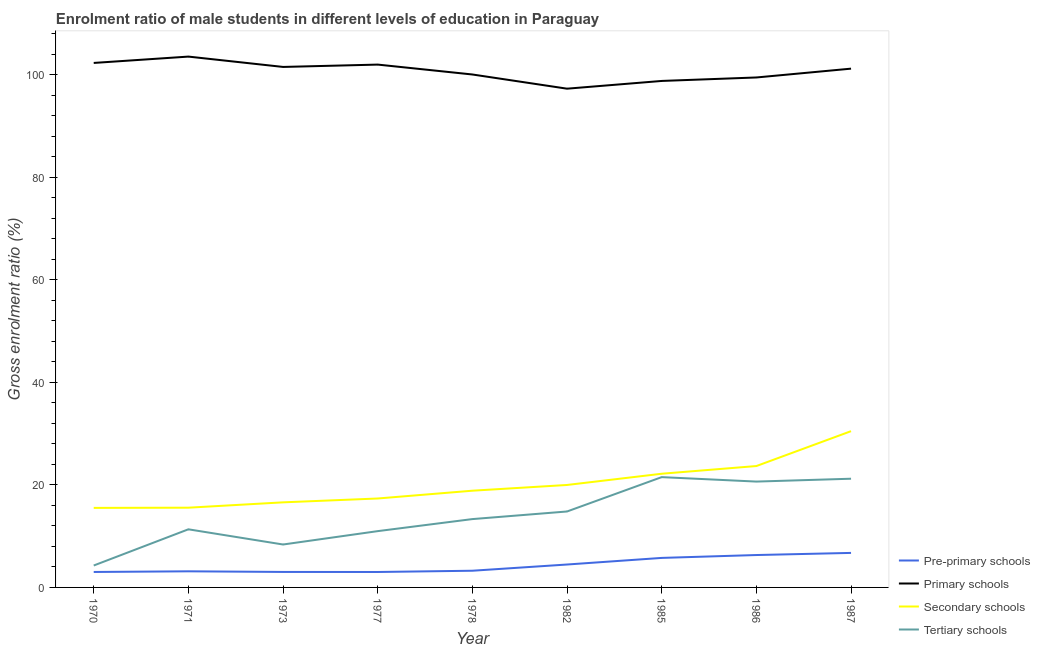Is the number of lines equal to the number of legend labels?
Offer a terse response. Yes. What is the gross enrolment ratio(female) in tertiary schools in 1977?
Make the answer very short. 10.99. Across all years, what is the maximum gross enrolment ratio(female) in tertiary schools?
Your answer should be compact. 21.53. Across all years, what is the minimum gross enrolment ratio(female) in tertiary schools?
Make the answer very short. 4.28. What is the total gross enrolment ratio(female) in primary schools in the graph?
Provide a succinct answer. 906.55. What is the difference between the gross enrolment ratio(female) in pre-primary schools in 1982 and that in 1987?
Provide a succinct answer. -2.26. What is the difference between the gross enrolment ratio(female) in tertiary schools in 1971 and the gross enrolment ratio(female) in pre-primary schools in 1973?
Offer a terse response. 8.32. What is the average gross enrolment ratio(female) in tertiary schools per year?
Ensure brevity in your answer.  14.06. In the year 1970, what is the difference between the gross enrolment ratio(female) in secondary schools and gross enrolment ratio(female) in primary schools?
Make the answer very short. -86.83. In how many years, is the gross enrolment ratio(female) in pre-primary schools greater than 4 %?
Provide a succinct answer. 4. What is the ratio of the gross enrolment ratio(female) in pre-primary schools in 1978 to that in 1985?
Give a very brief answer. 0.57. Is the difference between the gross enrolment ratio(female) in secondary schools in 1986 and 1987 greater than the difference between the gross enrolment ratio(female) in pre-primary schools in 1986 and 1987?
Keep it short and to the point. No. What is the difference between the highest and the second highest gross enrolment ratio(female) in pre-primary schools?
Keep it short and to the point. 0.41. What is the difference between the highest and the lowest gross enrolment ratio(female) in tertiary schools?
Keep it short and to the point. 17.25. Is the sum of the gross enrolment ratio(female) in primary schools in 1973 and 1978 greater than the maximum gross enrolment ratio(female) in pre-primary schools across all years?
Keep it short and to the point. Yes. Is it the case that in every year, the sum of the gross enrolment ratio(female) in pre-primary schools and gross enrolment ratio(female) in primary schools is greater than the sum of gross enrolment ratio(female) in secondary schools and gross enrolment ratio(female) in tertiary schools?
Offer a very short reply. Yes. Is it the case that in every year, the sum of the gross enrolment ratio(female) in pre-primary schools and gross enrolment ratio(female) in primary schools is greater than the gross enrolment ratio(female) in secondary schools?
Offer a very short reply. Yes. Does the gross enrolment ratio(female) in primary schools monotonically increase over the years?
Keep it short and to the point. No. How many lines are there?
Provide a short and direct response. 4. How many years are there in the graph?
Provide a short and direct response. 9. Are the values on the major ticks of Y-axis written in scientific E-notation?
Provide a short and direct response. No. Does the graph contain grids?
Your answer should be compact. No. How many legend labels are there?
Keep it short and to the point. 4. What is the title of the graph?
Provide a short and direct response. Enrolment ratio of male students in different levels of education in Paraguay. Does "WFP" appear as one of the legend labels in the graph?
Keep it short and to the point. No. What is the Gross enrolment ratio (%) of Pre-primary schools in 1970?
Ensure brevity in your answer.  3.02. What is the Gross enrolment ratio (%) in Primary schools in 1970?
Offer a very short reply. 102.35. What is the Gross enrolment ratio (%) of Secondary schools in 1970?
Offer a very short reply. 15.52. What is the Gross enrolment ratio (%) in Tertiary schools in 1970?
Provide a succinct answer. 4.28. What is the Gross enrolment ratio (%) of Pre-primary schools in 1971?
Your answer should be very brief. 3.14. What is the Gross enrolment ratio (%) in Primary schools in 1971?
Give a very brief answer. 103.59. What is the Gross enrolment ratio (%) of Secondary schools in 1971?
Keep it short and to the point. 15.56. What is the Gross enrolment ratio (%) in Tertiary schools in 1971?
Provide a short and direct response. 11.34. What is the Gross enrolment ratio (%) in Pre-primary schools in 1973?
Your answer should be very brief. 3.02. What is the Gross enrolment ratio (%) in Primary schools in 1973?
Your response must be concise. 101.57. What is the Gross enrolment ratio (%) in Secondary schools in 1973?
Provide a succinct answer. 16.6. What is the Gross enrolment ratio (%) in Tertiary schools in 1973?
Your answer should be compact. 8.38. What is the Gross enrolment ratio (%) of Pre-primary schools in 1977?
Your answer should be compact. 3.01. What is the Gross enrolment ratio (%) of Primary schools in 1977?
Your response must be concise. 102.03. What is the Gross enrolment ratio (%) in Secondary schools in 1977?
Provide a succinct answer. 17.36. What is the Gross enrolment ratio (%) of Tertiary schools in 1977?
Make the answer very short. 10.99. What is the Gross enrolment ratio (%) of Pre-primary schools in 1978?
Your answer should be compact. 3.26. What is the Gross enrolment ratio (%) of Primary schools in 1978?
Your answer should be very brief. 100.1. What is the Gross enrolment ratio (%) in Secondary schools in 1978?
Offer a very short reply. 18.88. What is the Gross enrolment ratio (%) of Tertiary schools in 1978?
Offer a terse response. 13.34. What is the Gross enrolment ratio (%) of Pre-primary schools in 1982?
Your answer should be compact. 4.47. What is the Gross enrolment ratio (%) of Primary schools in 1982?
Keep it short and to the point. 97.33. What is the Gross enrolment ratio (%) of Secondary schools in 1982?
Your response must be concise. 19.99. What is the Gross enrolment ratio (%) of Tertiary schools in 1982?
Provide a succinct answer. 14.82. What is the Gross enrolment ratio (%) of Pre-primary schools in 1985?
Offer a very short reply. 5.76. What is the Gross enrolment ratio (%) in Primary schools in 1985?
Your answer should be very brief. 98.84. What is the Gross enrolment ratio (%) in Secondary schools in 1985?
Give a very brief answer. 22.19. What is the Gross enrolment ratio (%) in Tertiary schools in 1985?
Keep it short and to the point. 21.53. What is the Gross enrolment ratio (%) of Pre-primary schools in 1986?
Your answer should be compact. 6.32. What is the Gross enrolment ratio (%) in Primary schools in 1986?
Your answer should be compact. 99.51. What is the Gross enrolment ratio (%) in Secondary schools in 1986?
Provide a succinct answer. 23.69. What is the Gross enrolment ratio (%) in Tertiary schools in 1986?
Provide a short and direct response. 20.66. What is the Gross enrolment ratio (%) of Pre-primary schools in 1987?
Offer a terse response. 6.74. What is the Gross enrolment ratio (%) in Primary schools in 1987?
Keep it short and to the point. 101.24. What is the Gross enrolment ratio (%) of Secondary schools in 1987?
Offer a terse response. 30.49. What is the Gross enrolment ratio (%) in Tertiary schools in 1987?
Your response must be concise. 21.21. Across all years, what is the maximum Gross enrolment ratio (%) in Pre-primary schools?
Offer a terse response. 6.74. Across all years, what is the maximum Gross enrolment ratio (%) of Primary schools?
Offer a terse response. 103.59. Across all years, what is the maximum Gross enrolment ratio (%) in Secondary schools?
Provide a short and direct response. 30.49. Across all years, what is the maximum Gross enrolment ratio (%) of Tertiary schools?
Provide a succinct answer. 21.53. Across all years, what is the minimum Gross enrolment ratio (%) in Pre-primary schools?
Ensure brevity in your answer.  3.01. Across all years, what is the minimum Gross enrolment ratio (%) of Primary schools?
Your answer should be compact. 97.33. Across all years, what is the minimum Gross enrolment ratio (%) of Secondary schools?
Provide a short and direct response. 15.52. Across all years, what is the minimum Gross enrolment ratio (%) of Tertiary schools?
Keep it short and to the point. 4.28. What is the total Gross enrolment ratio (%) of Pre-primary schools in the graph?
Give a very brief answer. 38.74. What is the total Gross enrolment ratio (%) in Primary schools in the graph?
Ensure brevity in your answer.  906.55. What is the total Gross enrolment ratio (%) in Secondary schools in the graph?
Offer a very short reply. 180.28. What is the total Gross enrolment ratio (%) of Tertiary schools in the graph?
Provide a short and direct response. 126.53. What is the difference between the Gross enrolment ratio (%) of Pre-primary schools in 1970 and that in 1971?
Keep it short and to the point. -0.13. What is the difference between the Gross enrolment ratio (%) in Primary schools in 1970 and that in 1971?
Provide a short and direct response. -1.24. What is the difference between the Gross enrolment ratio (%) of Secondary schools in 1970 and that in 1971?
Your answer should be very brief. -0.04. What is the difference between the Gross enrolment ratio (%) in Tertiary schools in 1970 and that in 1971?
Provide a short and direct response. -7.06. What is the difference between the Gross enrolment ratio (%) of Pre-primary schools in 1970 and that in 1973?
Offer a very short reply. -0.01. What is the difference between the Gross enrolment ratio (%) in Primary schools in 1970 and that in 1973?
Your answer should be compact. 0.78. What is the difference between the Gross enrolment ratio (%) in Secondary schools in 1970 and that in 1973?
Your answer should be very brief. -1.08. What is the difference between the Gross enrolment ratio (%) in Tertiary schools in 1970 and that in 1973?
Keep it short and to the point. -4.1. What is the difference between the Gross enrolment ratio (%) of Pre-primary schools in 1970 and that in 1977?
Keep it short and to the point. 0. What is the difference between the Gross enrolment ratio (%) of Primary schools in 1970 and that in 1977?
Ensure brevity in your answer.  0.32. What is the difference between the Gross enrolment ratio (%) of Secondary schools in 1970 and that in 1977?
Give a very brief answer. -1.83. What is the difference between the Gross enrolment ratio (%) of Tertiary schools in 1970 and that in 1977?
Your response must be concise. -6.71. What is the difference between the Gross enrolment ratio (%) in Pre-primary schools in 1970 and that in 1978?
Your response must be concise. -0.24. What is the difference between the Gross enrolment ratio (%) of Primary schools in 1970 and that in 1978?
Your response must be concise. 2.25. What is the difference between the Gross enrolment ratio (%) in Secondary schools in 1970 and that in 1978?
Your answer should be compact. -3.35. What is the difference between the Gross enrolment ratio (%) of Tertiary schools in 1970 and that in 1978?
Your answer should be very brief. -9.06. What is the difference between the Gross enrolment ratio (%) of Pre-primary schools in 1970 and that in 1982?
Your answer should be compact. -1.45. What is the difference between the Gross enrolment ratio (%) of Primary schools in 1970 and that in 1982?
Offer a very short reply. 5.02. What is the difference between the Gross enrolment ratio (%) in Secondary schools in 1970 and that in 1982?
Your response must be concise. -4.47. What is the difference between the Gross enrolment ratio (%) of Tertiary schools in 1970 and that in 1982?
Your answer should be compact. -10.54. What is the difference between the Gross enrolment ratio (%) in Pre-primary schools in 1970 and that in 1985?
Your response must be concise. -2.74. What is the difference between the Gross enrolment ratio (%) of Primary schools in 1970 and that in 1985?
Your answer should be compact. 3.51. What is the difference between the Gross enrolment ratio (%) of Secondary schools in 1970 and that in 1985?
Keep it short and to the point. -6.66. What is the difference between the Gross enrolment ratio (%) of Tertiary schools in 1970 and that in 1985?
Ensure brevity in your answer.  -17.25. What is the difference between the Gross enrolment ratio (%) in Pre-primary schools in 1970 and that in 1986?
Your response must be concise. -3.31. What is the difference between the Gross enrolment ratio (%) in Primary schools in 1970 and that in 1986?
Make the answer very short. 2.84. What is the difference between the Gross enrolment ratio (%) in Secondary schools in 1970 and that in 1986?
Provide a succinct answer. -8.17. What is the difference between the Gross enrolment ratio (%) in Tertiary schools in 1970 and that in 1986?
Keep it short and to the point. -16.38. What is the difference between the Gross enrolment ratio (%) of Pre-primary schools in 1970 and that in 1987?
Keep it short and to the point. -3.72. What is the difference between the Gross enrolment ratio (%) in Primary schools in 1970 and that in 1987?
Ensure brevity in your answer.  1.11. What is the difference between the Gross enrolment ratio (%) of Secondary schools in 1970 and that in 1987?
Make the answer very short. -14.97. What is the difference between the Gross enrolment ratio (%) of Tertiary schools in 1970 and that in 1987?
Offer a terse response. -16.94. What is the difference between the Gross enrolment ratio (%) in Pre-primary schools in 1971 and that in 1973?
Offer a very short reply. 0.12. What is the difference between the Gross enrolment ratio (%) in Primary schools in 1971 and that in 1973?
Give a very brief answer. 2.02. What is the difference between the Gross enrolment ratio (%) of Secondary schools in 1971 and that in 1973?
Keep it short and to the point. -1.04. What is the difference between the Gross enrolment ratio (%) of Tertiary schools in 1971 and that in 1973?
Give a very brief answer. 2.97. What is the difference between the Gross enrolment ratio (%) in Pre-primary schools in 1971 and that in 1977?
Provide a short and direct response. 0.13. What is the difference between the Gross enrolment ratio (%) of Primary schools in 1971 and that in 1977?
Provide a succinct answer. 1.56. What is the difference between the Gross enrolment ratio (%) of Secondary schools in 1971 and that in 1977?
Your response must be concise. -1.79. What is the difference between the Gross enrolment ratio (%) in Tertiary schools in 1971 and that in 1977?
Give a very brief answer. 0.36. What is the difference between the Gross enrolment ratio (%) of Pre-primary schools in 1971 and that in 1978?
Provide a succinct answer. -0.11. What is the difference between the Gross enrolment ratio (%) in Primary schools in 1971 and that in 1978?
Provide a short and direct response. 3.49. What is the difference between the Gross enrolment ratio (%) in Secondary schools in 1971 and that in 1978?
Keep it short and to the point. -3.32. What is the difference between the Gross enrolment ratio (%) in Tertiary schools in 1971 and that in 1978?
Keep it short and to the point. -1.99. What is the difference between the Gross enrolment ratio (%) in Pre-primary schools in 1971 and that in 1982?
Your answer should be very brief. -1.33. What is the difference between the Gross enrolment ratio (%) of Primary schools in 1971 and that in 1982?
Your answer should be compact. 6.26. What is the difference between the Gross enrolment ratio (%) in Secondary schools in 1971 and that in 1982?
Keep it short and to the point. -4.43. What is the difference between the Gross enrolment ratio (%) of Tertiary schools in 1971 and that in 1982?
Keep it short and to the point. -3.48. What is the difference between the Gross enrolment ratio (%) in Pre-primary schools in 1971 and that in 1985?
Give a very brief answer. -2.62. What is the difference between the Gross enrolment ratio (%) of Primary schools in 1971 and that in 1985?
Ensure brevity in your answer.  4.75. What is the difference between the Gross enrolment ratio (%) in Secondary schools in 1971 and that in 1985?
Your answer should be compact. -6.63. What is the difference between the Gross enrolment ratio (%) in Tertiary schools in 1971 and that in 1985?
Ensure brevity in your answer.  -10.18. What is the difference between the Gross enrolment ratio (%) of Pre-primary schools in 1971 and that in 1986?
Give a very brief answer. -3.18. What is the difference between the Gross enrolment ratio (%) of Primary schools in 1971 and that in 1986?
Offer a terse response. 4.07. What is the difference between the Gross enrolment ratio (%) of Secondary schools in 1971 and that in 1986?
Your answer should be compact. -8.13. What is the difference between the Gross enrolment ratio (%) in Tertiary schools in 1971 and that in 1986?
Your answer should be compact. -9.31. What is the difference between the Gross enrolment ratio (%) in Pre-primary schools in 1971 and that in 1987?
Offer a very short reply. -3.59. What is the difference between the Gross enrolment ratio (%) of Primary schools in 1971 and that in 1987?
Ensure brevity in your answer.  2.35. What is the difference between the Gross enrolment ratio (%) of Secondary schools in 1971 and that in 1987?
Make the answer very short. -14.93. What is the difference between the Gross enrolment ratio (%) of Tertiary schools in 1971 and that in 1987?
Make the answer very short. -9.87. What is the difference between the Gross enrolment ratio (%) of Pre-primary schools in 1973 and that in 1977?
Keep it short and to the point. 0.01. What is the difference between the Gross enrolment ratio (%) in Primary schools in 1973 and that in 1977?
Provide a short and direct response. -0.46. What is the difference between the Gross enrolment ratio (%) of Secondary schools in 1973 and that in 1977?
Provide a succinct answer. -0.75. What is the difference between the Gross enrolment ratio (%) of Tertiary schools in 1973 and that in 1977?
Make the answer very short. -2.61. What is the difference between the Gross enrolment ratio (%) in Pre-primary schools in 1973 and that in 1978?
Your response must be concise. -0.23. What is the difference between the Gross enrolment ratio (%) in Primary schools in 1973 and that in 1978?
Offer a very short reply. 1.47. What is the difference between the Gross enrolment ratio (%) of Secondary schools in 1973 and that in 1978?
Provide a succinct answer. -2.27. What is the difference between the Gross enrolment ratio (%) of Tertiary schools in 1973 and that in 1978?
Ensure brevity in your answer.  -4.96. What is the difference between the Gross enrolment ratio (%) in Pre-primary schools in 1973 and that in 1982?
Keep it short and to the point. -1.45. What is the difference between the Gross enrolment ratio (%) in Primary schools in 1973 and that in 1982?
Keep it short and to the point. 4.24. What is the difference between the Gross enrolment ratio (%) of Secondary schools in 1973 and that in 1982?
Provide a succinct answer. -3.39. What is the difference between the Gross enrolment ratio (%) in Tertiary schools in 1973 and that in 1982?
Make the answer very short. -6.44. What is the difference between the Gross enrolment ratio (%) in Pre-primary schools in 1973 and that in 1985?
Your response must be concise. -2.74. What is the difference between the Gross enrolment ratio (%) of Primary schools in 1973 and that in 1985?
Your answer should be compact. 2.73. What is the difference between the Gross enrolment ratio (%) in Secondary schools in 1973 and that in 1985?
Your response must be concise. -5.58. What is the difference between the Gross enrolment ratio (%) in Tertiary schools in 1973 and that in 1985?
Keep it short and to the point. -13.15. What is the difference between the Gross enrolment ratio (%) in Pre-primary schools in 1973 and that in 1986?
Your answer should be very brief. -3.3. What is the difference between the Gross enrolment ratio (%) of Primary schools in 1973 and that in 1986?
Your answer should be compact. 2.06. What is the difference between the Gross enrolment ratio (%) in Secondary schools in 1973 and that in 1986?
Your response must be concise. -7.08. What is the difference between the Gross enrolment ratio (%) of Tertiary schools in 1973 and that in 1986?
Make the answer very short. -12.28. What is the difference between the Gross enrolment ratio (%) in Pre-primary schools in 1973 and that in 1987?
Your response must be concise. -3.71. What is the difference between the Gross enrolment ratio (%) of Primary schools in 1973 and that in 1987?
Your answer should be compact. 0.34. What is the difference between the Gross enrolment ratio (%) of Secondary schools in 1973 and that in 1987?
Provide a succinct answer. -13.89. What is the difference between the Gross enrolment ratio (%) in Tertiary schools in 1973 and that in 1987?
Offer a terse response. -12.84. What is the difference between the Gross enrolment ratio (%) in Pre-primary schools in 1977 and that in 1978?
Keep it short and to the point. -0.24. What is the difference between the Gross enrolment ratio (%) in Primary schools in 1977 and that in 1978?
Ensure brevity in your answer.  1.93. What is the difference between the Gross enrolment ratio (%) in Secondary schools in 1977 and that in 1978?
Your response must be concise. -1.52. What is the difference between the Gross enrolment ratio (%) in Tertiary schools in 1977 and that in 1978?
Provide a short and direct response. -2.35. What is the difference between the Gross enrolment ratio (%) in Pre-primary schools in 1977 and that in 1982?
Your response must be concise. -1.46. What is the difference between the Gross enrolment ratio (%) in Primary schools in 1977 and that in 1982?
Ensure brevity in your answer.  4.7. What is the difference between the Gross enrolment ratio (%) in Secondary schools in 1977 and that in 1982?
Keep it short and to the point. -2.64. What is the difference between the Gross enrolment ratio (%) of Tertiary schools in 1977 and that in 1982?
Ensure brevity in your answer.  -3.83. What is the difference between the Gross enrolment ratio (%) of Pre-primary schools in 1977 and that in 1985?
Your answer should be very brief. -2.75. What is the difference between the Gross enrolment ratio (%) in Primary schools in 1977 and that in 1985?
Make the answer very short. 3.19. What is the difference between the Gross enrolment ratio (%) of Secondary schools in 1977 and that in 1985?
Ensure brevity in your answer.  -4.83. What is the difference between the Gross enrolment ratio (%) of Tertiary schools in 1977 and that in 1985?
Your answer should be compact. -10.54. What is the difference between the Gross enrolment ratio (%) of Pre-primary schools in 1977 and that in 1986?
Ensure brevity in your answer.  -3.31. What is the difference between the Gross enrolment ratio (%) in Primary schools in 1977 and that in 1986?
Ensure brevity in your answer.  2.51. What is the difference between the Gross enrolment ratio (%) of Secondary schools in 1977 and that in 1986?
Give a very brief answer. -6.33. What is the difference between the Gross enrolment ratio (%) in Tertiary schools in 1977 and that in 1986?
Offer a very short reply. -9.67. What is the difference between the Gross enrolment ratio (%) in Pre-primary schools in 1977 and that in 1987?
Your answer should be compact. -3.72. What is the difference between the Gross enrolment ratio (%) in Primary schools in 1977 and that in 1987?
Your answer should be compact. 0.79. What is the difference between the Gross enrolment ratio (%) in Secondary schools in 1977 and that in 1987?
Make the answer very short. -13.14. What is the difference between the Gross enrolment ratio (%) of Tertiary schools in 1977 and that in 1987?
Keep it short and to the point. -10.23. What is the difference between the Gross enrolment ratio (%) in Pre-primary schools in 1978 and that in 1982?
Give a very brief answer. -1.21. What is the difference between the Gross enrolment ratio (%) in Primary schools in 1978 and that in 1982?
Give a very brief answer. 2.77. What is the difference between the Gross enrolment ratio (%) of Secondary schools in 1978 and that in 1982?
Provide a short and direct response. -1.12. What is the difference between the Gross enrolment ratio (%) in Tertiary schools in 1978 and that in 1982?
Keep it short and to the point. -1.48. What is the difference between the Gross enrolment ratio (%) in Pre-primary schools in 1978 and that in 1985?
Offer a very short reply. -2.5. What is the difference between the Gross enrolment ratio (%) in Primary schools in 1978 and that in 1985?
Offer a very short reply. 1.26. What is the difference between the Gross enrolment ratio (%) in Secondary schools in 1978 and that in 1985?
Provide a succinct answer. -3.31. What is the difference between the Gross enrolment ratio (%) of Tertiary schools in 1978 and that in 1985?
Provide a succinct answer. -8.19. What is the difference between the Gross enrolment ratio (%) in Pre-primary schools in 1978 and that in 1986?
Offer a very short reply. -3.06. What is the difference between the Gross enrolment ratio (%) of Primary schools in 1978 and that in 1986?
Your answer should be very brief. 0.58. What is the difference between the Gross enrolment ratio (%) of Secondary schools in 1978 and that in 1986?
Make the answer very short. -4.81. What is the difference between the Gross enrolment ratio (%) of Tertiary schools in 1978 and that in 1986?
Ensure brevity in your answer.  -7.32. What is the difference between the Gross enrolment ratio (%) in Pre-primary schools in 1978 and that in 1987?
Offer a terse response. -3.48. What is the difference between the Gross enrolment ratio (%) of Primary schools in 1978 and that in 1987?
Ensure brevity in your answer.  -1.14. What is the difference between the Gross enrolment ratio (%) in Secondary schools in 1978 and that in 1987?
Your response must be concise. -11.62. What is the difference between the Gross enrolment ratio (%) of Tertiary schools in 1978 and that in 1987?
Your response must be concise. -7.88. What is the difference between the Gross enrolment ratio (%) in Pre-primary schools in 1982 and that in 1985?
Give a very brief answer. -1.29. What is the difference between the Gross enrolment ratio (%) of Primary schools in 1982 and that in 1985?
Your answer should be compact. -1.51. What is the difference between the Gross enrolment ratio (%) in Secondary schools in 1982 and that in 1985?
Keep it short and to the point. -2.19. What is the difference between the Gross enrolment ratio (%) of Tertiary schools in 1982 and that in 1985?
Your response must be concise. -6.71. What is the difference between the Gross enrolment ratio (%) in Pre-primary schools in 1982 and that in 1986?
Provide a succinct answer. -1.85. What is the difference between the Gross enrolment ratio (%) of Primary schools in 1982 and that in 1986?
Provide a succinct answer. -2.19. What is the difference between the Gross enrolment ratio (%) of Secondary schools in 1982 and that in 1986?
Your answer should be very brief. -3.69. What is the difference between the Gross enrolment ratio (%) of Tertiary schools in 1982 and that in 1986?
Offer a terse response. -5.84. What is the difference between the Gross enrolment ratio (%) of Pre-primary schools in 1982 and that in 1987?
Offer a very short reply. -2.26. What is the difference between the Gross enrolment ratio (%) in Primary schools in 1982 and that in 1987?
Provide a short and direct response. -3.91. What is the difference between the Gross enrolment ratio (%) in Secondary schools in 1982 and that in 1987?
Your answer should be very brief. -10.5. What is the difference between the Gross enrolment ratio (%) in Tertiary schools in 1982 and that in 1987?
Provide a short and direct response. -6.39. What is the difference between the Gross enrolment ratio (%) of Pre-primary schools in 1985 and that in 1986?
Keep it short and to the point. -0.56. What is the difference between the Gross enrolment ratio (%) in Primary schools in 1985 and that in 1986?
Give a very brief answer. -0.68. What is the difference between the Gross enrolment ratio (%) of Secondary schools in 1985 and that in 1986?
Make the answer very short. -1.5. What is the difference between the Gross enrolment ratio (%) in Tertiary schools in 1985 and that in 1986?
Give a very brief answer. 0.87. What is the difference between the Gross enrolment ratio (%) in Pre-primary schools in 1985 and that in 1987?
Ensure brevity in your answer.  -0.98. What is the difference between the Gross enrolment ratio (%) in Primary schools in 1985 and that in 1987?
Provide a short and direct response. -2.4. What is the difference between the Gross enrolment ratio (%) of Secondary schools in 1985 and that in 1987?
Provide a short and direct response. -8.31. What is the difference between the Gross enrolment ratio (%) of Tertiary schools in 1985 and that in 1987?
Your answer should be compact. 0.31. What is the difference between the Gross enrolment ratio (%) in Pre-primary schools in 1986 and that in 1987?
Offer a very short reply. -0.41. What is the difference between the Gross enrolment ratio (%) in Primary schools in 1986 and that in 1987?
Make the answer very short. -1.72. What is the difference between the Gross enrolment ratio (%) in Secondary schools in 1986 and that in 1987?
Your response must be concise. -6.81. What is the difference between the Gross enrolment ratio (%) in Tertiary schools in 1986 and that in 1987?
Provide a short and direct response. -0.56. What is the difference between the Gross enrolment ratio (%) in Pre-primary schools in 1970 and the Gross enrolment ratio (%) in Primary schools in 1971?
Make the answer very short. -100.57. What is the difference between the Gross enrolment ratio (%) in Pre-primary schools in 1970 and the Gross enrolment ratio (%) in Secondary schools in 1971?
Your answer should be compact. -12.54. What is the difference between the Gross enrolment ratio (%) of Pre-primary schools in 1970 and the Gross enrolment ratio (%) of Tertiary schools in 1971?
Provide a short and direct response. -8.33. What is the difference between the Gross enrolment ratio (%) of Primary schools in 1970 and the Gross enrolment ratio (%) of Secondary schools in 1971?
Ensure brevity in your answer.  86.79. What is the difference between the Gross enrolment ratio (%) of Primary schools in 1970 and the Gross enrolment ratio (%) of Tertiary schools in 1971?
Keep it short and to the point. 91.01. What is the difference between the Gross enrolment ratio (%) in Secondary schools in 1970 and the Gross enrolment ratio (%) in Tertiary schools in 1971?
Your response must be concise. 4.18. What is the difference between the Gross enrolment ratio (%) of Pre-primary schools in 1970 and the Gross enrolment ratio (%) of Primary schools in 1973?
Ensure brevity in your answer.  -98.55. What is the difference between the Gross enrolment ratio (%) of Pre-primary schools in 1970 and the Gross enrolment ratio (%) of Secondary schools in 1973?
Offer a terse response. -13.59. What is the difference between the Gross enrolment ratio (%) in Pre-primary schools in 1970 and the Gross enrolment ratio (%) in Tertiary schools in 1973?
Keep it short and to the point. -5.36. What is the difference between the Gross enrolment ratio (%) in Primary schools in 1970 and the Gross enrolment ratio (%) in Secondary schools in 1973?
Your answer should be compact. 85.75. What is the difference between the Gross enrolment ratio (%) of Primary schools in 1970 and the Gross enrolment ratio (%) of Tertiary schools in 1973?
Give a very brief answer. 93.97. What is the difference between the Gross enrolment ratio (%) in Secondary schools in 1970 and the Gross enrolment ratio (%) in Tertiary schools in 1973?
Your answer should be compact. 7.14. What is the difference between the Gross enrolment ratio (%) of Pre-primary schools in 1970 and the Gross enrolment ratio (%) of Primary schools in 1977?
Give a very brief answer. -99.01. What is the difference between the Gross enrolment ratio (%) of Pre-primary schools in 1970 and the Gross enrolment ratio (%) of Secondary schools in 1977?
Provide a short and direct response. -14.34. What is the difference between the Gross enrolment ratio (%) in Pre-primary schools in 1970 and the Gross enrolment ratio (%) in Tertiary schools in 1977?
Give a very brief answer. -7.97. What is the difference between the Gross enrolment ratio (%) of Primary schools in 1970 and the Gross enrolment ratio (%) of Secondary schools in 1977?
Your response must be concise. 85. What is the difference between the Gross enrolment ratio (%) in Primary schools in 1970 and the Gross enrolment ratio (%) in Tertiary schools in 1977?
Provide a short and direct response. 91.36. What is the difference between the Gross enrolment ratio (%) in Secondary schools in 1970 and the Gross enrolment ratio (%) in Tertiary schools in 1977?
Keep it short and to the point. 4.54. What is the difference between the Gross enrolment ratio (%) of Pre-primary schools in 1970 and the Gross enrolment ratio (%) of Primary schools in 1978?
Keep it short and to the point. -97.08. What is the difference between the Gross enrolment ratio (%) of Pre-primary schools in 1970 and the Gross enrolment ratio (%) of Secondary schools in 1978?
Keep it short and to the point. -15.86. What is the difference between the Gross enrolment ratio (%) in Pre-primary schools in 1970 and the Gross enrolment ratio (%) in Tertiary schools in 1978?
Provide a succinct answer. -10.32. What is the difference between the Gross enrolment ratio (%) of Primary schools in 1970 and the Gross enrolment ratio (%) of Secondary schools in 1978?
Offer a very short reply. 83.47. What is the difference between the Gross enrolment ratio (%) in Primary schools in 1970 and the Gross enrolment ratio (%) in Tertiary schools in 1978?
Provide a succinct answer. 89.02. What is the difference between the Gross enrolment ratio (%) of Secondary schools in 1970 and the Gross enrolment ratio (%) of Tertiary schools in 1978?
Provide a succinct answer. 2.19. What is the difference between the Gross enrolment ratio (%) of Pre-primary schools in 1970 and the Gross enrolment ratio (%) of Primary schools in 1982?
Your answer should be compact. -94.31. What is the difference between the Gross enrolment ratio (%) in Pre-primary schools in 1970 and the Gross enrolment ratio (%) in Secondary schools in 1982?
Offer a very short reply. -16.98. What is the difference between the Gross enrolment ratio (%) of Pre-primary schools in 1970 and the Gross enrolment ratio (%) of Tertiary schools in 1982?
Your answer should be very brief. -11.8. What is the difference between the Gross enrolment ratio (%) of Primary schools in 1970 and the Gross enrolment ratio (%) of Secondary schools in 1982?
Offer a very short reply. 82.36. What is the difference between the Gross enrolment ratio (%) of Primary schools in 1970 and the Gross enrolment ratio (%) of Tertiary schools in 1982?
Offer a terse response. 87.53. What is the difference between the Gross enrolment ratio (%) in Secondary schools in 1970 and the Gross enrolment ratio (%) in Tertiary schools in 1982?
Your response must be concise. 0.7. What is the difference between the Gross enrolment ratio (%) of Pre-primary schools in 1970 and the Gross enrolment ratio (%) of Primary schools in 1985?
Offer a terse response. -95.82. What is the difference between the Gross enrolment ratio (%) in Pre-primary schools in 1970 and the Gross enrolment ratio (%) in Secondary schools in 1985?
Keep it short and to the point. -19.17. What is the difference between the Gross enrolment ratio (%) of Pre-primary schools in 1970 and the Gross enrolment ratio (%) of Tertiary schools in 1985?
Ensure brevity in your answer.  -18.51. What is the difference between the Gross enrolment ratio (%) in Primary schools in 1970 and the Gross enrolment ratio (%) in Secondary schools in 1985?
Your response must be concise. 80.16. What is the difference between the Gross enrolment ratio (%) in Primary schools in 1970 and the Gross enrolment ratio (%) in Tertiary schools in 1985?
Keep it short and to the point. 80.82. What is the difference between the Gross enrolment ratio (%) of Secondary schools in 1970 and the Gross enrolment ratio (%) of Tertiary schools in 1985?
Offer a very short reply. -6. What is the difference between the Gross enrolment ratio (%) in Pre-primary schools in 1970 and the Gross enrolment ratio (%) in Primary schools in 1986?
Keep it short and to the point. -96.5. What is the difference between the Gross enrolment ratio (%) in Pre-primary schools in 1970 and the Gross enrolment ratio (%) in Secondary schools in 1986?
Provide a succinct answer. -20.67. What is the difference between the Gross enrolment ratio (%) in Pre-primary schools in 1970 and the Gross enrolment ratio (%) in Tertiary schools in 1986?
Keep it short and to the point. -17.64. What is the difference between the Gross enrolment ratio (%) of Primary schools in 1970 and the Gross enrolment ratio (%) of Secondary schools in 1986?
Make the answer very short. 78.66. What is the difference between the Gross enrolment ratio (%) of Primary schools in 1970 and the Gross enrolment ratio (%) of Tertiary schools in 1986?
Provide a short and direct response. 81.69. What is the difference between the Gross enrolment ratio (%) of Secondary schools in 1970 and the Gross enrolment ratio (%) of Tertiary schools in 1986?
Your answer should be compact. -5.13. What is the difference between the Gross enrolment ratio (%) of Pre-primary schools in 1970 and the Gross enrolment ratio (%) of Primary schools in 1987?
Your answer should be very brief. -98.22. What is the difference between the Gross enrolment ratio (%) of Pre-primary schools in 1970 and the Gross enrolment ratio (%) of Secondary schools in 1987?
Give a very brief answer. -27.48. What is the difference between the Gross enrolment ratio (%) in Pre-primary schools in 1970 and the Gross enrolment ratio (%) in Tertiary schools in 1987?
Keep it short and to the point. -18.2. What is the difference between the Gross enrolment ratio (%) of Primary schools in 1970 and the Gross enrolment ratio (%) of Secondary schools in 1987?
Your response must be concise. 71.86. What is the difference between the Gross enrolment ratio (%) of Primary schools in 1970 and the Gross enrolment ratio (%) of Tertiary schools in 1987?
Offer a terse response. 81.14. What is the difference between the Gross enrolment ratio (%) of Secondary schools in 1970 and the Gross enrolment ratio (%) of Tertiary schools in 1987?
Keep it short and to the point. -5.69. What is the difference between the Gross enrolment ratio (%) of Pre-primary schools in 1971 and the Gross enrolment ratio (%) of Primary schools in 1973?
Ensure brevity in your answer.  -98.43. What is the difference between the Gross enrolment ratio (%) of Pre-primary schools in 1971 and the Gross enrolment ratio (%) of Secondary schools in 1973?
Your answer should be compact. -13.46. What is the difference between the Gross enrolment ratio (%) of Pre-primary schools in 1971 and the Gross enrolment ratio (%) of Tertiary schools in 1973?
Your answer should be compact. -5.23. What is the difference between the Gross enrolment ratio (%) in Primary schools in 1971 and the Gross enrolment ratio (%) in Secondary schools in 1973?
Ensure brevity in your answer.  86.99. What is the difference between the Gross enrolment ratio (%) of Primary schools in 1971 and the Gross enrolment ratio (%) of Tertiary schools in 1973?
Give a very brief answer. 95.21. What is the difference between the Gross enrolment ratio (%) of Secondary schools in 1971 and the Gross enrolment ratio (%) of Tertiary schools in 1973?
Your response must be concise. 7.18. What is the difference between the Gross enrolment ratio (%) of Pre-primary schools in 1971 and the Gross enrolment ratio (%) of Primary schools in 1977?
Provide a short and direct response. -98.88. What is the difference between the Gross enrolment ratio (%) of Pre-primary schools in 1971 and the Gross enrolment ratio (%) of Secondary schools in 1977?
Give a very brief answer. -14.21. What is the difference between the Gross enrolment ratio (%) in Pre-primary schools in 1971 and the Gross enrolment ratio (%) in Tertiary schools in 1977?
Your answer should be compact. -7.84. What is the difference between the Gross enrolment ratio (%) in Primary schools in 1971 and the Gross enrolment ratio (%) in Secondary schools in 1977?
Ensure brevity in your answer.  86.23. What is the difference between the Gross enrolment ratio (%) in Primary schools in 1971 and the Gross enrolment ratio (%) in Tertiary schools in 1977?
Keep it short and to the point. 92.6. What is the difference between the Gross enrolment ratio (%) in Secondary schools in 1971 and the Gross enrolment ratio (%) in Tertiary schools in 1977?
Ensure brevity in your answer.  4.57. What is the difference between the Gross enrolment ratio (%) of Pre-primary schools in 1971 and the Gross enrolment ratio (%) of Primary schools in 1978?
Offer a very short reply. -96.95. What is the difference between the Gross enrolment ratio (%) of Pre-primary schools in 1971 and the Gross enrolment ratio (%) of Secondary schools in 1978?
Provide a succinct answer. -15.73. What is the difference between the Gross enrolment ratio (%) in Pre-primary schools in 1971 and the Gross enrolment ratio (%) in Tertiary schools in 1978?
Ensure brevity in your answer.  -10.19. What is the difference between the Gross enrolment ratio (%) in Primary schools in 1971 and the Gross enrolment ratio (%) in Secondary schools in 1978?
Offer a terse response. 84.71. What is the difference between the Gross enrolment ratio (%) of Primary schools in 1971 and the Gross enrolment ratio (%) of Tertiary schools in 1978?
Your answer should be compact. 90.25. What is the difference between the Gross enrolment ratio (%) of Secondary schools in 1971 and the Gross enrolment ratio (%) of Tertiary schools in 1978?
Offer a terse response. 2.23. What is the difference between the Gross enrolment ratio (%) of Pre-primary schools in 1971 and the Gross enrolment ratio (%) of Primary schools in 1982?
Your response must be concise. -94.18. What is the difference between the Gross enrolment ratio (%) in Pre-primary schools in 1971 and the Gross enrolment ratio (%) in Secondary schools in 1982?
Give a very brief answer. -16.85. What is the difference between the Gross enrolment ratio (%) in Pre-primary schools in 1971 and the Gross enrolment ratio (%) in Tertiary schools in 1982?
Your answer should be compact. -11.67. What is the difference between the Gross enrolment ratio (%) of Primary schools in 1971 and the Gross enrolment ratio (%) of Secondary schools in 1982?
Ensure brevity in your answer.  83.59. What is the difference between the Gross enrolment ratio (%) in Primary schools in 1971 and the Gross enrolment ratio (%) in Tertiary schools in 1982?
Offer a very short reply. 88.77. What is the difference between the Gross enrolment ratio (%) of Secondary schools in 1971 and the Gross enrolment ratio (%) of Tertiary schools in 1982?
Your response must be concise. 0.74. What is the difference between the Gross enrolment ratio (%) in Pre-primary schools in 1971 and the Gross enrolment ratio (%) in Primary schools in 1985?
Offer a very short reply. -95.69. What is the difference between the Gross enrolment ratio (%) in Pre-primary schools in 1971 and the Gross enrolment ratio (%) in Secondary schools in 1985?
Offer a very short reply. -19.04. What is the difference between the Gross enrolment ratio (%) in Pre-primary schools in 1971 and the Gross enrolment ratio (%) in Tertiary schools in 1985?
Give a very brief answer. -18.38. What is the difference between the Gross enrolment ratio (%) in Primary schools in 1971 and the Gross enrolment ratio (%) in Secondary schools in 1985?
Make the answer very short. 81.4. What is the difference between the Gross enrolment ratio (%) in Primary schools in 1971 and the Gross enrolment ratio (%) in Tertiary schools in 1985?
Provide a succinct answer. 82.06. What is the difference between the Gross enrolment ratio (%) of Secondary schools in 1971 and the Gross enrolment ratio (%) of Tertiary schools in 1985?
Ensure brevity in your answer.  -5.97. What is the difference between the Gross enrolment ratio (%) in Pre-primary schools in 1971 and the Gross enrolment ratio (%) in Primary schools in 1986?
Offer a very short reply. -96.37. What is the difference between the Gross enrolment ratio (%) in Pre-primary schools in 1971 and the Gross enrolment ratio (%) in Secondary schools in 1986?
Your response must be concise. -20.54. What is the difference between the Gross enrolment ratio (%) of Pre-primary schools in 1971 and the Gross enrolment ratio (%) of Tertiary schools in 1986?
Give a very brief answer. -17.51. What is the difference between the Gross enrolment ratio (%) of Primary schools in 1971 and the Gross enrolment ratio (%) of Secondary schools in 1986?
Your answer should be very brief. 79.9. What is the difference between the Gross enrolment ratio (%) in Primary schools in 1971 and the Gross enrolment ratio (%) in Tertiary schools in 1986?
Keep it short and to the point. 82.93. What is the difference between the Gross enrolment ratio (%) of Secondary schools in 1971 and the Gross enrolment ratio (%) of Tertiary schools in 1986?
Make the answer very short. -5.1. What is the difference between the Gross enrolment ratio (%) of Pre-primary schools in 1971 and the Gross enrolment ratio (%) of Primary schools in 1987?
Your response must be concise. -98.09. What is the difference between the Gross enrolment ratio (%) in Pre-primary schools in 1971 and the Gross enrolment ratio (%) in Secondary schools in 1987?
Give a very brief answer. -27.35. What is the difference between the Gross enrolment ratio (%) of Pre-primary schools in 1971 and the Gross enrolment ratio (%) of Tertiary schools in 1987?
Your answer should be very brief. -18.07. What is the difference between the Gross enrolment ratio (%) in Primary schools in 1971 and the Gross enrolment ratio (%) in Secondary schools in 1987?
Provide a short and direct response. 73.1. What is the difference between the Gross enrolment ratio (%) in Primary schools in 1971 and the Gross enrolment ratio (%) in Tertiary schools in 1987?
Provide a succinct answer. 82.38. What is the difference between the Gross enrolment ratio (%) in Secondary schools in 1971 and the Gross enrolment ratio (%) in Tertiary schools in 1987?
Give a very brief answer. -5.65. What is the difference between the Gross enrolment ratio (%) of Pre-primary schools in 1973 and the Gross enrolment ratio (%) of Primary schools in 1977?
Your answer should be compact. -99.01. What is the difference between the Gross enrolment ratio (%) in Pre-primary schools in 1973 and the Gross enrolment ratio (%) in Secondary schools in 1977?
Provide a short and direct response. -14.33. What is the difference between the Gross enrolment ratio (%) in Pre-primary schools in 1973 and the Gross enrolment ratio (%) in Tertiary schools in 1977?
Make the answer very short. -7.96. What is the difference between the Gross enrolment ratio (%) of Primary schools in 1973 and the Gross enrolment ratio (%) of Secondary schools in 1977?
Offer a very short reply. 84.22. What is the difference between the Gross enrolment ratio (%) in Primary schools in 1973 and the Gross enrolment ratio (%) in Tertiary schools in 1977?
Ensure brevity in your answer.  90.59. What is the difference between the Gross enrolment ratio (%) in Secondary schools in 1973 and the Gross enrolment ratio (%) in Tertiary schools in 1977?
Make the answer very short. 5.62. What is the difference between the Gross enrolment ratio (%) of Pre-primary schools in 1973 and the Gross enrolment ratio (%) of Primary schools in 1978?
Provide a short and direct response. -97.07. What is the difference between the Gross enrolment ratio (%) of Pre-primary schools in 1973 and the Gross enrolment ratio (%) of Secondary schools in 1978?
Ensure brevity in your answer.  -15.85. What is the difference between the Gross enrolment ratio (%) in Pre-primary schools in 1973 and the Gross enrolment ratio (%) in Tertiary schools in 1978?
Offer a terse response. -10.31. What is the difference between the Gross enrolment ratio (%) in Primary schools in 1973 and the Gross enrolment ratio (%) in Secondary schools in 1978?
Provide a short and direct response. 82.7. What is the difference between the Gross enrolment ratio (%) of Primary schools in 1973 and the Gross enrolment ratio (%) of Tertiary schools in 1978?
Offer a terse response. 88.24. What is the difference between the Gross enrolment ratio (%) in Secondary schools in 1973 and the Gross enrolment ratio (%) in Tertiary schools in 1978?
Ensure brevity in your answer.  3.27. What is the difference between the Gross enrolment ratio (%) in Pre-primary schools in 1973 and the Gross enrolment ratio (%) in Primary schools in 1982?
Ensure brevity in your answer.  -94.3. What is the difference between the Gross enrolment ratio (%) of Pre-primary schools in 1973 and the Gross enrolment ratio (%) of Secondary schools in 1982?
Provide a succinct answer. -16.97. What is the difference between the Gross enrolment ratio (%) in Pre-primary schools in 1973 and the Gross enrolment ratio (%) in Tertiary schools in 1982?
Ensure brevity in your answer.  -11.8. What is the difference between the Gross enrolment ratio (%) in Primary schools in 1973 and the Gross enrolment ratio (%) in Secondary schools in 1982?
Your answer should be very brief. 81.58. What is the difference between the Gross enrolment ratio (%) in Primary schools in 1973 and the Gross enrolment ratio (%) in Tertiary schools in 1982?
Provide a succinct answer. 86.75. What is the difference between the Gross enrolment ratio (%) of Secondary schools in 1973 and the Gross enrolment ratio (%) of Tertiary schools in 1982?
Keep it short and to the point. 1.78. What is the difference between the Gross enrolment ratio (%) of Pre-primary schools in 1973 and the Gross enrolment ratio (%) of Primary schools in 1985?
Your answer should be very brief. -95.81. What is the difference between the Gross enrolment ratio (%) of Pre-primary schools in 1973 and the Gross enrolment ratio (%) of Secondary schools in 1985?
Keep it short and to the point. -19.16. What is the difference between the Gross enrolment ratio (%) of Pre-primary schools in 1973 and the Gross enrolment ratio (%) of Tertiary schools in 1985?
Provide a short and direct response. -18.5. What is the difference between the Gross enrolment ratio (%) of Primary schools in 1973 and the Gross enrolment ratio (%) of Secondary schools in 1985?
Ensure brevity in your answer.  79.39. What is the difference between the Gross enrolment ratio (%) of Primary schools in 1973 and the Gross enrolment ratio (%) of Tertiary schools in 1985?
Offer a very short reply. 80.05. What is the difference between the Gross enrolment ratio (%) in Secondary schools in 1973 and the Gross enrolment ratio (%) in Tertiary schools in 1985?
Your response must be concise. -4.92. What is the difference between the Gross enrolment ratio (%) of Pre-primary schools in 1973 and the Gross enrolment ratio (%) of Primary schools in 1986?
Offer a very short reply. -96.49. What is the difference between the Gross enrolment ratio (%) in Pre-primary schools in 1973 and the Gross enrolment ratio (%) in Secondary schools in 1986?
Give a very brief answer. -20.66. What is the difference between the Gross enrolment ratio (%) of Pre-primary schools in 1973 and the Gross enrolment ratio (%) of Tertiary schools in 1986?
Your answer should be very brief. -17.63. What is the difference between the Gross enrolment ratio (%) of Primary schools in 1973 and the Gross enrolment ratio (%) of Secondary schools in 1986?
Offer a terse response. 77.88. What is the difference between the Gross enrolment ratio (%) of Primary schools in 1973 and the Gross enrolment ratio (%) of Tertiary schools in 1986?
Your answer should be very brief. 80.92. What is the difference between the Gross enrolment ratio (%) of Secondary schools in 1973 and the Gross enrolment ratio (%) of Tertiary schools in 1986?
Your answer should be compact. -4.05. What is the difference between the Gross enrolment ratio (%) in Pre-primary schools in 1973 and the Gross enrolment ratio (%) in Primary schools in 1987?
Provide a succinct answer. -98.21. What is the difference between the Gross enrolment ratio (%) in Pre-primary schools in 1973 and the Gross enrolment ratio (%) in Secondary schools in 1987?
Offer a terse response. -27.47. What is the difference between the Gross enrolment ratio (%) of Pre-primary schools in 1973 and the Gross enrolment ratio (%) of Tertiary schools in 1987?
Provide a succinct answer. -18.19. What is the difference between the Gross enrolment ratio (%) in Primary schools in 1973 and the Gross enrolment ratio (%) in Secondary schools in 1987?
Provide a short and direct response. 71.08. What is the difference between the Gross enrolment ratio (%) of Primary schools in 1973 and the Gross enrolment ratio (%) of Tertiary schools in 1987?
Give a very brief answer. 80.36. What is the difference between the Gross enrolment ratio (%) in Secondary schools in 1973 and the Gross enrolment ratio (%) in Tertiary schools in 1987?
Offer a very short reply. -4.61. What is the difference between the Gross enrolment ratio (%) of Pre-primary schools in 1977 and the Gross enrolment ratio (%) of Primary schools in 1978?
Offer a very short reply. -97.08. What is the difference between the Gross enrolment ratio (%) of Pre-primary schools in 1977 and the Gross enrolment ratio (%) of Secondary schools in 1978?
Your response must be concise. -15.86. What is the difference between the Gross enrolment ratio (%) of Pre-primary schools in 1977 and the Gross enrolment ratio (%) of Tertiary schools in 1978?
Keep it short and to the point. -10.32. What is the difference between the Gross enrolment ratio (%) in Primary schools in 1977 and the Gross enrolment ratio (%) in Secondary schools in 1978?
Keep it short and to the point. 83.15. What is the difference between the Gross enrolment ratio (%) in Primary schools in 1977 and the Gross enrolment ratio (%) in Tertiary schools in 1978?
Make the answer very short. 88.69. What is the difference between the Gross enrolment ratio (%) in Secondary schools in 1977 and the Gross enrolment ratio (%) in Tertiary schools in 1978?
Offer a very short reply. 4.02. What is the difference between the Gross enrolment ratio (%) of Pre-primary schools in 1977 and the Gross enrolment ratio (%) of Primary schools in 1982?
Make the answer very short. -94.31. What is the difference between the Gross enrolment ratio (%) in Pre-primary schools in 1977 and the Gross enrolment ratio (%) in Secondary schools in 1982?
Your answer should be very brief. -16.98. What is the difference between the Gross enrolment ratio (%) of Pre-primary schools in 1977 and the Gross enrolment ratio (%) of Tertiary schools in 1982?
Ensure brevity in your answer.  -11.81. What is the difference between the Gross enrolment ratio (%) in Primary schools in 1977 and the Gross enrolment ratio (%) in Secondary schools in 1982?
Make the answer very short. 82.03. What is the difference between the Gross enrolment ratio (%) of Primary schools in 1977 and the Gross enrolment ratio (%) of Tertiary schools in 1982?
Your answer should be very brief. 87.21. What is the difference between the Gross enrolment ratio (%) of Secondary schools in 1977 and the Gross enrolment ratio (%) of Tertiary schools in 1982?
Provide a short and direct response. 2.54. What is the difference between the Gross enrolment ratio (%) in Pre-primary schools in 1977 and the Gross enrolment ratio (%) in Primary schools in 1985?
Offer a terse response. -95.82. What is the difference between the Gross enrolment ratio (%) in Pre-primary schools in 1977 and the Gross enrolment ratio (%) in Secondary schools in 1985?
Your response must be concise. -19.17. What is the difference between the Gross enrolment ratio (%) in Pre-primary schools in 1977 and the Gross enrolment ratio (%) in Tertiary schools in 1985?
Offer a very short reply. -18.51. What is the difference between the Gross enrolment ratio (%) of Primary schools in 1977 and the Gross enrolment ratio (%) of Secondary schools in 1985?
Ensure brevity in your answer.  79.84. What is the difference between the Gross enrolment ratio (%) of Primary schools in 1977 and the Gross enrolment ratio (%) of Tertiary schools in 1985?
Your response must be concise. 80.5. What is the difference between the Gross enrolment ratio (%) in Secondary schools in 1977 and the Gross enrolment ratio (%) in Tertiary schools in 1985?
Your answer should be very brief. -4.17. What is the difference between the Gross enrolment ratio (%) of Pre-primary schools in 1977 and the Gross enrolment ratio (%) of Primary schools in 1986?
Provide a succinct answer. -96.5. What is the difference between the Gross enrolment ratio (%) of Pre-primary schools in 1977 and the Gross enrolment ratio (%) of Secondary schools in 1986?
Keep it short and to the point. -20.67. What is the difference between the Gross enrolment ratio (%) of Pre-primary schools in 1977 and the Gross enrolment ratio (%) of Tertiary schools in 1986?
Provide a succinct answer. -17.64. What is the difference between the Gross enrolment ratio (%) of Primary schools in 1977 and the Gross enrolment ratio (%) of Secondary schools in 1986?
Your response must be concise. 78.34. What is the difference between the Gross enrolment ratio (%) of Primary schools in 1977 and the Gross enrolment ratio (%) of Tertiary schools in 1986?
Give a very brief answer. 81.37. What is the difference between the Gross enrolment ratio (%) of Secondary schools in 1977 and the Gross enrolment ratio (%) of Tertiary schools in 1986?
Your answer should be very brief. -3.3. What is the difference between the Gross enrolment ratio (%) in Pre-primary schools in 1977 and the Gross enrolment ratio (%) in Primary schools in 1987?
Ensure brevity in your answer.  -98.22. What is the difference between the Gross enrolment ratio (%) in Pre-primary schools in 1977 and the Gross enrolment ratio (%) in Secondary schools in 1987?
Your response must be concise. -27.48. What is the difference between the Gross enrolment ratio (%) in Pre-primary schools in 1977 and the Gross enrolment ratio (%) in Tertiary schools in 1987?
Make the answer very short. -18.2. What is the difference between the Gross enrolment ratio (%) in Primary schools in 1977 and the Gross enrolment ratio (%) in Secondary schools in 1987?
Make the answer very short. 71.53. What is the difference between the Gross enrolment ratio (%) of Primary schools in 1977 and the Gross enrolment ratio (%) of Tertiary schools in 1987?
Keep it short and to the point. 80.82. What is the difference between the Gross enrolment ratio (%) of Secondary schools in 1977 and the Gross enrolment ratio (%) of Tertiary schools in 1987?
Your answer should be compact. -3.86. What is the difference between the Gross enrolment ratio (%) of Pre-primary schools in 1978 and the Gross enrolment ratio (%) of Primary schools in 1982?
Offer a very short reply. -94.07. What is the difference between the Gross enrolment ratio (%) of Pre-primary schools in 1978 and the Gross enrolment ratio (%) of Secondary schools in 1982?
Ensure brevity in your answer.  -16.74. What is the difference between the Gross enrolment ratio (%) of Pre-primary schools in 1978 and the Gross enrolment ratio (%) of Tertiary schools in 1982?
Provide a succinct answer. -11.56. What is the difference between the Gross enrolment ratio (%) of Primary schools in 1978 and the Gross enrolment ratio (%) of Secondary schools in 1982?
Provide a succinct answer. 80.1. What is the difference between the Gross enrolment ratio (%) in Primary schools in 1978 and the Gross enrolment ratio (%) in Tertiary schools in 1982?
Make the answer very short. 85.28. What is the difference between the Gross enrolment ratio (%) in Secondary schools in 1978 and the Gross enrolment ratio (%) in Tertiary schools in 1982?
Offer a terse response. 4.06. What is the difference between the Gross enrolment ratio (%) of Pre-primary schools in 1978 and the Gross enrolment ratio (%) of Primary schools in 1985?
Give a very brief answer. -95.58. What is the difference between the Gross enrolment ratio (%) in Pre-primary schools in 1978 and the Gross enrolment ratio (%) in Secondary schools in 1985?
Provide a short and direct response. -18.93. What is the difference between the Gross enrolment ratio (%) in Pre-primary schools in 1978 and the Gross enrolment ratio (%) in Tertiary schools in 1985?
Offer a very short reply. -18.27. What is the difference between the Gross enrolment ratio (%) of Primary schools in 1978 and the Gross enrolment ratio (%) of Secondary schools in 1985?
Provide a short and direct response. 77.91. What is the difference between the Gross enrolment ratio (%) in Primary schools in 1978 and the Gross enrolment ratio (%) in Tertiary schools in 1985?
Your response must be concise. 78.57. What is the difference between the Gross enrolment ratio (%) in Secondary schools in 1978 and the Gross enrolment ratio (%) in Tertiary schools in 1985?
Offer a terse response. -2.65. What is the difference between the Gross enrolment ratio (%) of Pre-primary schools in 1978 and the Gross enrolment ratio (%) of Primary schools in 1986?
Ensure brevity in your answer.  -96.26. What is the difference between the Gross enrolment ratio (%) of Pre-primary schools in 1978 and the Gross enrolment ratio (%) of Secondary schools in 1986?
Keep it short and to the point. -20.43. What is the difference between the Gross enrolment ratio (%) of Pre-primary schools in 1978 and the Gross enrolment ratio (%) of Tertiary schools in 1986?
Make the answer very short. -17.4. What is the difference between the Gross enrolment ratio (%) in Primary schools in 1978 and the Gross enrolment ratio (%) in Secondary schools in 1986?
Provide a short and direct response. 76.41. What is the difference between the Gross enrolment ratio (%) of Primary schools in 1978 and the Gross enrolment ratio (%) of Tertiary schools in 1986?
Your answer should be very brief. 79.44. What is the difference between the Gross enrolment ratio (%) in Secondary schools in 1978 and the Gross enrolment ratio (%) in Tertiary schools in 1986?
Offer a terse response. -1.78. What is the difference between the Gross enrolment ratio (%) of Pre-primary schools in 1978 and the Gross enrolment ratio (%) of Primary schools in 1987?
Give a very brief answer. -97.98. What is the difference between the Gross enrolment ratio (%) in Pre-primary schools in 1978 and the Gross enrolment ratio (%) in Secondary schools in 1987?
Your answer should be compact. -27.24. What is the difference between the Gross enrolment ratio (%) in Pre-primary schools in 1978 and the Gross enrolment ratio (%) in Tertiary schools in 1987?
Your response must be concise. -17.96. What is the difference between the Gross enrolment ratio (%) in Primary schools in 1978 and the Gross enrolment ratio (%) in Secondary schools in 1987?
Offer a terse response. 69.6. What is the difference between the Gross enrolment ratio (%) in Primary schools in 1978 and the Gross enrolment ratio (%) in Tertiary schools in 1987?
Ensure brevity in your answer.  78.88. What is the difference between the Gross enrolment ratio (%) in Secondary schools in 1978 and the Gross enrolment ratio (%) in Tertiary schools in 1987?
Make the answer very short. -2.34. What is the difference between the Gross enrolment ratio (%) in Pre-primary schools in 1982 and the Gross enrolment ratio (%) in Primary schools in 1985?
Offer a very short reply. -94.37. What is the difference between the Gross enrolment ratio (%) in Pre-primary schools in 1982 and the Gross enrolment ratio (%) in Secondary schools in 1985?
Your response must be concise. -17.72. What is the difference between the Gross enrolment ratio (%) of Pre-primary schools in 1982 and the Gross enrolment ratio (%) of Tertiary schools in 1985?
Make the answer very short. -17.06. What is the difference between the Gross enrolment ratio (%) in Primary schools in 1982 and the Gross enrolment ratio (%) in Secondary schools in 1985?
Ensure brevity in your answer.  75.14. What is the difference between the Gross enrolment ratio (%) in Primary schools in 1982 and the Gross enrolment ratio (%) in Tertiary schools in 1985?
Keep it short and to the point. 75.8. What is the difference between the Gross enrolment ratio (%) of Secondary schools in 1982 and the Gross enrolment ratio (%) of Tertiary schools in 1985?
Keep it short and to the point. -1.53. What is the difference between the Gross enrolment ratio (%) of Pre-primary schools in 1982 and the Gross enrolment ratio (%) of Primary schools in 1986?
Keep it short and to the point. -95.04. What is the difference between the Gross enrolment ratio (%) of Pre-primary schools in 1982 and the Gross enrolment ratio (%) of Secondary schools in 1986?
Keep it short and to the point. -19.22. What is the difference between the Gross enrolment ratio (%) of Pre-primary schools in 1982 and the Gross enrolment ratio (%) of Tertiary schools in 1986?
Your answer should be compact. -16.19. What is the difference between the Gross enrolment ratio (%) of Primary schools in 1982 and the Gross enrolment ratio (%) of Secondary schools in 1986?
Give a very brief answer. 73.64. What is the difference between the Gross enrolment ratio (%) of Primary schools in 1982 and the Gross enrolment ratio (%) of Tertiary schools in 1986?
Your answer should be very brief. 76.67. What is the difference between the Gross enrolment ratio (%) in Secondary schools in 1982 and the Gross enrolment ratio (%) in Tertiary schools in 1986?
Your answer should be very brief. -0.66. What is the difference between the Gross enrolment ratio (%) of Pre-primary schools in 1982 and the Gross enrolment ratio (%) of Primary schools in 1987?
Offer a terse response. -96.77. What is the difference between the Gross enrolment ratio (%) of Pre-primary schools in 1982 and the Gross enrolment ratio (%) of Secondary schools in 1987?
Provide a short and direct response. -26.02. What is the difference between the Gross enrolment ratio (%) in Pre-primary schools in 1982 and the Gross enrolment ratio (%) in Tertiary schools in 1987?
Keep it short and to the point. -16.74. What is the difference between the Gross enrolment ratio (%) in Primary schools in 1982 and the Gross enrolment ratio (%) in Secondary schools in 1987?
Offer a very short reply. 66.83. What is the difference between the Gross enrolment ratio (%) in Primary schools in 1982 and the Gross enrolment ratio (%) in Tertiary schools in 1987?
Provide a short and direct response. 76.11. What is the difference between the Gross enrolment ratio (%) in Secondary schools in 1982 and the Gross enrolment ratio (%) in Tertiary schools in 1987?
Provide a short and direct response. -1.22. What is the difference between the Gross enrolment ratio (%) in Pre-primary schools in 1985 and the Gross enrolment ratio (%) in Primary schools in 1986?
Give a very brief answer. -93.75. What is the difference between the Gross enrolment ratio (%) of Pre-primary schools in 1985 and the Gross enrolment ratio (%) of Secondary schools in 1986?
Provide a short and direct response. -17.93. What is the difference between the Gross enrolment ratio (%) in Pre-primary schools in 1985 and the Gross enrolment ratio (%) in Tertiary schools in 1986?
Your answer should be compact. -14.9. What is the difference between the Gross enrolment ratio (%) of Primary schools in 1985 and the Gross enrolment ratio (%) of Secondary schools in 1986?
Give a very brief answer. 75.15. What is the difference between the Gross enrolment ratio (%) in Primary schools in 1985 and the Gross enrolment ratio (%) in Tertiary schools in 1986?
Your response must be concise. 78.18. What is the difference between the Gross enrolment ratio (%) in Secondary schools in 1985 and the Gross enrolment ratio (%) in Tertiary schools in 1986?
Ensure brevity in your answer.  1.53. What is the difference between the Gross enrolment ratio (%) in Pre-primary schools in 1985 and the Gross enrolment ratio (%) in Primary schools in 1987?
Make the answer very short. -95.48. What is the difference between the Gross enrolment ratio (%) in Pre-primary schools in 1985 and the Gross enrolment ratio (%) in Secondary schools in 1987?
Offer a very short reply. -24.73. What is the difference between the Gross enrolment ratio (%) of Pre-primary schools in 1985 and the Gross enrolment ratio (%) of Tertiary schools in 1987?
Your response must be concise. -15.45. What is the difference between the Gross enrolment ratio (%) of Primary schools in 1985 and the Gross enrolment ratio (%) of Secondary schools in 1987?
Provide a short and direct response. 68.34. What is the difference between the Gross enrolment ratio (%) in Primary schools in 1985 and the Gross enrolment ratio (%) in Tertiary schools in 1987?
Provide a short and direct response. 77.62. What is the difference between the Gross enrolment ratio (%) in Secondary schools in 1985 and the Gross enrolment ratio (%) in Tertiary schools in 1987?
Offer a terse response. 0.97. What is the difference between the Gross enrolment ratio (%) in Pre-primary schools in 1986 and the Gross enrolment ratio (%) in Primary schools in 1987?
Give a very brief answer. -94.91. What is the difference between the Gross enrolment ratio (%) of Pre-primary schools in 1986 and the Gross enrolment ratio (%) of Secondary schools in 1987?
Offer a terse response. -24.17. What is the difference between the Gross enrolment ratio (%) of Pre-primary schools in 1986 and the Gross enrolment ratio (%) of Tertiary schools in 1987?
Your response must be concise. -14.89. What is the difference between the Gross enrolment ratio (%) of Primary schools in 1986 and the Gross enrolment ratio (%) of Secondary schools in 1987?
Keep it short and to the point. 69.02. What is the difference between the Gross enrolment ratio (%) in Primary schools in 1986 and the Gross enrolment ratio (%) in Tertiary schools in 1987?
Provide a short and direct response. 78.3. What is the difference between the Gross enrolment ratio (%) of Secondary schools in 1986 and the Gross enrolment ratio (%) of Tertiary schools in 1987?
Offer a terse response. 2.47. What is the average Gross enrolment ratio (%) in Pre-primary schools per year?
Make the answer very short. 4.3. What is the average Gross enrolment ratio (%) in Primary schools per year?
Ensure brevity in your answer.  100.73. What is the average Gross enrolment ratio (%) of Secondary schools per year?
Your answer should be compact. 20.03. What is the average Gross enrolment ratio (%) in Tertiary schools per year?
Provide a short and direct response. 14.06. In the year 1970, what is the difference between the Gross enrolment ratio (%) of Pre-primary schools and Gross enrolment ratio (%) of Primary schools?
Give a very brief answer. -99.33. In the year 1970, what is the difference between the Gross enrolment ratio (%) in Pre-primary schools and Gross enrolment ratio (%) in Secondary schools?
Keep it short and to the point. -12.5. In the year 1970, what is the difference between the Gross enrolment ratio (%) in Pre-primary schools and Gross enrolment ratio (%) in Tertiary schools?
Make the answer very short. -1.26. In the year 1970, what is the difference between the Gross enrolment ratio (%) of Primary schools and Gross enrolment ratio (%) of Secondary schools?
Your answer should be compact. 86.83. In the year 1970, what is the difference between the Gross enrolment ratio (%) in Primary schools and Gross enrolment ratio (%) in Tertiary schools?
Provide a succinct answer. 98.07. In the year 1970, what is the difference between the Gross enrolment ratio (%) in Secondary schools and Gross enrolment ratio (%) in Tertiary schools?
Provide a succinct answer. 11.24. In the year 1971, what is the difference between the Gross enrolment ratio (%) in Pre-primary schools and Gross enrolment ratio (%) in Primary schools?
Provide a short and direct response. -100.44. In the year 1971, what is the difference between the Gross enrolment ratio (%) in Pre-primary schools and Gross enrolment ratio (%) in Secondary schools?
Offer a very short reply. -12.42. In the year 1971, what is the difference between the Gross enrolment ratio (%) of Pre-primary schools and Gross enrolment ratio (%) of Tertiary schools?
Offer a very short reply. -8.2. In the year 1971, what is the difference between the Gross enrolment ratio (%) in Primary schools and Gross enrolment ratio (%) in Secondary schools?
Provide a succinct answer. 88.03. In the year 1971, what is the difference between the Gross enrolment ratio (%) in Primary schools and Gross enrolment ratio (%) in Tertiary schools?
Your answer should be very brief. 92.25. In the year 1971, what is the difference between the Gross enrolment ratio (%) of Secondary schools and Gross enrolment ratio (%) of Tertiary schools?
Give a very brief answer. 4.22. In the year 1973, what is the difference between the Gross enrolment ratio (%) in Pre-primary schools and Gross enrolment ratio (%) in Primary schools?
Your response must be concise. -98.55. In the year 1973, what is the difference between the Gross enrolment ratio (%) of Pre-primary schools and Gross enrolment ratio (%) of Secondary schools?
Offer a terse response. -13.58. In the year 1973, what is the difference between the Gross enrolment ratio (%) in Pre-primary schools and Gross enrolment ratio (%) in Tertiary schools?
Provide a succinct answer. -5.35. In the year 1973, what is the difference between the Gross enrolment ratio (%) in Primary schools and Gross enrolment ratio (%) in Secondary schools?
Provide a short and direct response. 84.97. In the year 1973, what is the difference between the Gross enrolment ratio (%) in Primary schools and Gross enrolment ratio (%) in Tertiary schools?
Ensure brevity in your answer.  93.19. In the year 1973, what is the difference between the Gross enrolment ratio (%) of Secondary schools and Gross enrolment ratio (%) of Tertiary schools?
Your answer should be very brief. 8.23. In the year 1977, what is the difference between the Gross enrolment ratio (%) of Pre-primary schools and Gross enrolment ratio (%) of Primary schools?
Offer a terse response. -99.01. In the year 1977, what is the difference between the Gross enrolment ratio (%) in Pre-primary schools and Gross enrolment ratio (%) in Secondary schools?
Give a very brief answer. -14.34. In the year 1977, what is the difference between the Gross enrolment ratio (%) in Pre-primary schools and Gross enrolment ratio (%) in Tertiary schools?
Ensure brevity in your answer.  -7.97. In the year 1977, what is the difference between the Gross enrolment ratio (%) in Primary schools and Gross enrolment ratio (%) in Secondary schools?
Keep it short and to the point. 84.67. In the year 1977, what is the difference between the Gross enrolment ratio (%) in Primary schools and Gross enrolment ratio (%) in Tertiary schools?
Make the answer very short. 91.04. In the year 1977, what is the difference between the Gross enrolment ratio (%) of Secondary schools and Gross enrolment ratio (%) of Tertiary schools?
Provide a short and direct response. 6.37. In the year 1978, what is the difference between the Gross enrolment ratio (%) in Pre-primary schools and Gross enrolment ratio (%) in Primary schools?
Provide a short and direct response. -96.84. In the year 1978, what is the difference between the Gross enrolment ratio (%) of Pre-primary schools and Gross enrolment ratio (%) of Secondary schools?
Keep it short and to the point. -15.62. In the year 1978, what is the difference between the Gross enrolment ratio (%) in Pre-primary schools and Gross enrolment ratio (%) in Tertiary schools?
Your response must be concise. -10.08. In the year 1978, what is the difference between the Gross enrolment ratio (%) in Primary schools and Gross enrolment ratio (%) in Secondary schools?
Provide a short and direct response. 81.22. In the year 1978, what is the difference between the Gross enrolment ratio (%) in Primary schools and Gross enrolment ratio (%) in Tertiary schools?
Offer a very short reply. 86.76. In the year 1978, what is the difference between the Gross enrolment ratio (%) of Secondary schools and Gross enrolment ratio (%) of Tertiary schools?
Give a very brief answer. 5.54. In the year 1982, what is the difference between the Gross enrolment ratio (%) of Pre-primary schools and Gross enrolment ratio (%) of Primary schools?
Your response must be concise. -92.86. In the year 1982, what is the difference between the Gross enrolment ratio (%) of Pre-primary schools and Gross enrolment ratio (%) of Secondary schools?
Give a very brief answer. -15.52. In the year 1982, what is the difference between the Gross enrolment ratio (%) of Pre-primary schools and Gross enrolment ratio (%) of Tertiary schools?
Offer a very short reply. -10.35. In the year 1982, what is the difference between the Gross enrolment ratio (%) of Primary schools and Gross enrolment ratio (%) of Secondary schools?
Offer a terse response. 77.33. In the year 1982, what is the difference between the Gross enrolment ratio (%) of Primary schools and Gross enrolment ratio (%) of Tertiary schools?
Your response must be concise. 82.51. In the year 1982, what is the difference between the Gross enrolment ratio (%) in Secondary schools and Gross enrolment ratio (%) in Tertiary schools?
Give a very brief answer. 5.17. In the year 1985, what is the difference between the Gross enrolment ratio (%) in Pre-primary schools and Gross enrolment ratio (%) in Primary schools?
Keep it short and to the point. -93.08. In the year 1985, what is the difference between the Gross enrolment ratio (%) in Pre-primary schools and Gross enrolment ratio (%) in Secondary schools?
Offer a terse response. -16.43. In the year 1985, what is the difference between the Gross enrolment ratio (%) in Pre-primary schools and Gross enrolment ratio (%) in Tertiary schools?
Your response must be concise. -15.77. In the year 1985, what is the difference between the Gross enrolment ratio (%) in Primary schools and Gross enrolment ratio (%) in Secondary schools?
Provide a short and direct response. 76.65. In the year 1985, what is the difference between the Gross enrolment ratio (%) in Primary schools and Gross enrolment ratio (%) in Tertiary schools?
Your answer should be very brief. 77.31. In the year 1985, what is the difference between the Gross enrolment ratio (%) in Secondary schools and Gross enrolment ratio (%) in Tertiary schools?
Offer a terse response. 0.66. In the year 1986, what is the difference between the Gross enrolment ratio (%) of Pre-primary schools and Gross enrolment ratio (%) of Primary schools?
Ensure brevity in your answer.  -93.19. In the year 1986, what is the difference between the Gross enrolment ratio (%) in Pre-primary schools and Gross enrolment ratio (%) in Secondary schools?
Provide a short and direct response. -17.37. In the year 1986, what is the difference between the Gross enrolment ratio (%) of Pre-primary schools and Gross enrolment ratio (%) of Tertiary schools?
Offer a very short reply. -14.33. In the year 1986, what is the difference between the Gross enrolment ratio (%) of Primary schools and Gross enrolment ratio (%) of Secondary schools?
Make the answer very short. 75.83. In the year 1986, what is the difference between the Gross enrolment ratio (%) in Primary schools and Gross enrolment ratio (%) in Tertiary schools?
Keep it short and to the point. 78.86. In the year 1986, what is the difference between the Gross enrolment ratio (%) of Secondary schools and Gross enrolment ratio (%) of Tertiary schools?
Give a very brief answer. 3.03. In the year 1987, what is the difference between the Gross enrolment ratio (%) of Pre-primary schools and Gross enrolment ratio (%) of Primary schools?
Ensure brevity in your answer.  -94.5. In the year 1987, what is the difference between the Gross enrolment ratio (%) in Pre-primary schools and Gross enrolment ratio (%) in Secondary schools?
Your response must be concise. -23.76. In the year 1987, what is the difference between the Gross enrolment ratio (%) in Pre-primary schools and Gross enrolment ratio (%) in Tertiary schools?
Provide a succinct answer. -14.48. In the year 1987, what is the difference between the Gross enrolment ratio (%) in Primary schools and Gross enrolment ratio (%) in Secondary schools?
Provide a succinct answer. 70.74. In the year 1987, what is the difference between the Gross enrolment ratio (%) in Primary schools and Gross enrolment ratio (%) in Tertiary schools?
Your answer should be very brief. 80.02. In the year 1987, what is the difference between the Gross enrolment ratio (%) in Secondary schools and Gross enrolment ratio (%) in Tertiary schools?
Provide a short and direct response. 9.28. What is the ratio of the Gross enrolment ratio (%) of Pre-primary schools in 1970 to that in 1971?
Ensure brevity in your answer.  0.96. What is the ratio of the Gross enrolment ratio (%) of Tertiary schools in 1970 to that in 1971?
Make the answer very short. 0.38. What is the ratio of the Gross enrolment ratio (%) of Primary schools in 1970 to that in 1973?
Provide a succinct answer. 1.01. What is the ratio of the Gross enrolment ratio (%) of Secondary schools in 1970 to that in 1973?
Your answer should be very brief. 0.93. What is the ratio of the Gross enrolment ratio (%) in Tertiary schools in 1970 to that in 1973?
Keep it short and to the point. 0.51. What is the ratio of the Gross enrolment ratio (%) of Secondary schools in 1970 to that in 1977?
Your response must be concise. 0.89. What is the ratio of the Gross enrolment ratio (%) of Tertiary schools in 1970 to that in 1977?
Ensure brevity in your answer.  0.39. What is the ratio of the Gross enrolment ratio (%) of Pre-primary schools in 1970 to that in 1978?
Your answer should be very brief. 0.93. What is the ratio of the Gross enrolment ratio (%) in Primary schools in 1970 to that in 1978?
Offer a terse response. 1.02. What is the ratio of the Gross enrolment ratio (%) in Secondary schools in 1970 to that in 1978?
Your answer should be compact. 0.82. What is the ratio of the Gross enrolment ratio (%) in Tertiary schools in 1970 to that in 1978?
Offer a very short reply. 0.32. What is the ratio of the Gross enrolment ratio (%) of Pre-primary schools in 1970 to that in 1982?
Your response must be concise. 0.67. What is the ratio of the Gross enrolment ratio (%) of Primary schools in 1970 to that in 1982?
Give a very brief answer. 1.05. What is the ratio of the Gross enrolment ratio (%) in Secondary schools in 1970 to that in 1982?
Give a very brief answer. 0.78. What is the ratio of the Gross enrolment ratio (%) of Tertiary schools in 1970 to that in 1982?
Offer a very short reply. 0.29. What is the ratio of the Gross enrolment ratio (%) in Pre-primary schools in 1970 to that in 1985?
Ensure brevity in your answer.  0.52. What is the ratio of the Gross enrolment ratio (%) in Primary schools in 1970 to that in 1985?
Provide a short and direct response. 1.04. What is the ratio of the Gross enrolment ratio (%) in Secondary schools in 1970 to that in 1985?
Your answer should be compact. 0.7. What is the ratio of the Gross enrolment ratio (%) in Tertiary schools in 1970 to that in 1985?
Offer a very short reply. 0.2. What is the ratio of the Gross enrolment ratio (%) in Pre-primary schools in 1970 to that in 1986?
Your answer should be very brief. 0.48. What is the ratio of the Gross enrolment ratio (%) of Primary schools in 1970 to that in 1986?
Provide a short and direct response. 1.03. What is the ratio of the Gross enrolment ratio (%) of Secondary schools in 1970 to that in 1986?
Offer a terse response. 0.66. What is the ratio of the Gross enrolment ratio (%) in Tertiary schools in 1970 to that in 1986?
Make the answer very short. 0.21. What is the ratio of the Gross enrolment ratio (%) in Pre-primary schools in 1970 to that in 1987?
Offer a terse response. 0.45. What is the ratio of the Gross enrolment ratio (%) of Secondary schools in 1970 to that in 1987?
Ensure brevity in your answer.  0.51. What is the ratio of the Gross enrolment ratio (%) of Tertiary schools in 1970 to that in 1987?
Ensure brevity in your answer.  0.2. What is the ratio of the Gross enrolment ratio (%) in Pre-primary schools in 1971 to that in 1973?
Provide a succinct answer. 1.04. What is the ratio of the Gross enrolment ratio (%) in Primary schools in 1971 to that in 1973?
Ensure brevity in your answer.  1.02. What is the ratio of the Gross enrolment ratio (%) in Secondary schools in 1971 to that in 1973?
Offer a terse response. 0.94. What is the ratio of the Gross enrolment ratio (%) of Tertiary schools in 1971 to that in 1973?
Make the answer very short. 1.35. What is the ratio of the Gross enrolment ratio (%) in Pre-primary schools in 1971 to that in 1977?
Your answer should be compact. 1.04. What is the ratio of the Gross enrolment ratio (%) of Primary schools in 1971 to that in 1977?
Provide a succinct answer. 1.02. What is the ratio of the Gross enrolment ratio (%) of Secondary schools in 1971 to that in 1977?
Your answer should be compact. 0.9. What is the ratio of the Gross enrolment ratio (%) in Tertiary schools in 1971 to that in 1977?
Your answer should be compact. 1.03. What is the ratio of the Gross enrolment ratio (%) of Pre-primary schools in 1971 to that in 1978?
Ensure brevity in your answer.  0.97. What is the ratio of the Gross enrolment ratio (%) in Primary schools in 1971 to that in 1978?
Offer a terse response. 1.03. What is the ratio of the Gross enrolment ratio (%) in Secondary schools in 1971 to that in 1978?
Offer a very short reply. 0.82. What is the ratio of the Gross enrolment ratio (%) of Tertiary schools in 1971 to that in 1978?
Provide a short and direct response. 0.85. What is the ratio of the Gross enrolment ratio (%) in Pre-primary schools in 1971 to that in 1982?
Offer a terse response. 0.7. What is the ratio of the Gross enrolment ratio (%) of Primary schools in 1971 to that in 1982?
Give a very brief answer. 1.06. What is the ratio of the Gross enrolment ratio (%) of Secondary schools in 1971 to that in 1982?
Your answer should be very brief. 0.78. What is the ratio of the Gross enrolment ratio (%) of Tertiary schools in 1971 to that in 1982?
Keep it short and to the point. 0.77. What is the ratio of the Gross enrolment ratio (%) of Pre-primary schools in 1971 to that in 1985?
Give a very brief answer. 0.55. What is the ratio of the Gross enrolment ratio (%) in Primary schools in 1971 to that in 1985?
Your response must be concise. 1.05. What is the ratio of the Gross enrolment ratio (%) in Secondary schools in 1971 to that in 1985?
Your answer should be compact. 0.7. What is the ratio of the Gross enrolment ratio (%) of Tertiary schools in 1971 to that in 1985?
Your answer should be compact. 0.53. What is the ratio of the Gross enrolment ratio (%) of Pre-primary schools in 1971 to that in 1986?
Your answer should be very brief. 0.5. What is the ratio of the Gross enrolment ratio (%) in Primary schools in 1971 to that in 1986?
Offer a terse response. 1.04. What is the ratio of the Gross enrolment ratio (%) in Secondary schools in 1971 to that in 1986?
Keep it short and to the point. 0.66. What is the ratio of the Gross enrolment ratio (%) of Tertiary schools in 1971 to that in 1986?
Offer a very short reply. 0.55. What is the ratio of the Gross enrolment ratio (%) of Pre-primary schools in 1971 to that in 1987?
Provide a short and direct response. 0.47. What is the ratio of the Gross enrolment ratio (%) in Primary schools in 1971 to that in 1987?
Your response must be concise. 1.02. What is the ratio of the Gross enrolment ratio (%) in Secondary schools in 1971 to that in 1987?
Offer a terse response. 0.51. What is the ratio of the Gross enrolment ratio (%) of Tertiary schools in 1971 to that in 1987?
Make the answer very short. 0.53. What is the ratio of the Gross enrolment ratio (%) of Secondary schools in 1973 to that in 1977?
Provide a succinct answer. 0.96. What is the ratio of the Gross enrolment ratio (%) in Tertiary schools in 1973 to that in 1977?
Give a very brief answer. 0.76. What is the ratio of the Gross enrolment ratio (%) of Pre-primary schools in 1973 to that in 1978?
Your answer should be compact. 0.93. What is the ratio of the Gross enrolment ratio (%) of Primary schools in 1973 to that in 1978?
Ensure brevity in your answer.  1.01. What is the ratio of the Gross enrolment ratio (%) in Secondary schools in 1973 to that in 1978?
Ensure brevity in your answer.  0.88. What is the ratio of the Gross enrolment ratio (%) of Tertiary schools in 1973 to that in 1978?
Your answer should be compact. 0.63. What is the ratio of the Gross enrolment ratio (%) in Pre-primary schools in 1973 to that in 1982?
Keep it short and to the point. 0.68. What is the ratio of the Gross enrolment ratio (%) in Primary schools in 1973 to that in 1982?
Your answer should be very brief. 1.04. What is the ratio of the Gross enrolment ratio (%) in Secondary schools in 1973 to that in 1982?
Offer a terse response. 0.83. What is the ratio of the Gross enrolment ratio (%) in Tertiary schools in 1973 to that in 1982?
Offer a very short reply. 0.57. What is the ratio of the Gross enrolment ratio (%) of Pre-primary schools in 1973 to that in 1985?
Your response must be concise. 0.52. What is the ratio of the Gross enrolment ratio (%) of Primary schools in 1973 to that in 1985?
Keep it short and to the point. 1.03. What is the ratio of the Gross enrolment ratio (%) in Secondary schools in 1973 to that in 1985?
Give a very brief answer. 0.75. What is the ratio of the Gross enrolment ratio (%) in Tertiary schools in 1973 to that in 1985?
Your response must be concise. 0.39. What is the ratio of the Gross enrolment ratio (%) of Pre-primary schools in 1973 to that in 1986?
Your response must be concise. 0.48. What is the ratio of the Gross enrolment ratio (%) in Primary schools in 1973 to that in 1986?
Offer a terse response. 1.02. What is the ratio of the Gross enrolment ratio (%) of Secondary schools in 1973 to that in 1986?
Give a very brief answer. 0.7. What is the ratio of the Gross enrolment ratio (%) of Tertiary schools in 1973 to that in 1986?
Your answer should be compact. 0.41. What is the ratio of the Gross enrolment ratio (%) of Pre-primary schools in 1973 to that in 1987?
Ensure brevity in your answer.  0.45. What is the ratio of the Gross enrolment ratio (%) in Primary schools in 1973 to that in 1987?
Provide a succinct answer. 1. What is the ratio of the Gross enrolment ratio (%) of Secondary schools in 1973 to that in 1987?
Give a very brief answer. 0.54. What is the ratio of the Gross enrolment ratio (%) in Tertiary schools in 1973 to that in 1987?
Offer a terse response. 0.39. What is the ratio of the Gross enrolment ratio (%) of Pre-primary schools in 1977 to that in 1978?
Keep it short and to the point. 0.93. What is the ratio of the Gross enrolment ratio (%) in Primary schools in 1977 to that in 1978?
Your response must be concise. 1.02. What is the ratio of the Gross enrolment ratio (%) of Secondary schools in 1977 to that in 1978?
Keep it short and to the point. 0.92. What is the ratio of the Gross enrolment ratio (%) of Tertiary schools in 1977 to that in 1978?
Provide a succinct answer. 0.82. What is the ratio of the Gross enrolment ratio (%) in Pre-primary schools in 1977 to that in 1982?
Make the answer very short. 0.67. What is the ratio of the Gross enrolment ratio (%) of Primary schools in 1977 to that in 1982?
Your answer should be very brief. 1.05. What is the ratio of the Gross enrolment ratio (%) of Secondary schools in 1977 to that in 1982?
Your answer should be very brief. 0.87. What is the ratio of the Gross enrolment ratio (%) in Tertiary schools in 1977 to that in 1982?
Your answer should be compact. 0.74. What is the ratio of the Gross enrolment ratio (%) of Pre-primary schools in 1977 to that in 1985?
Offer a terse response. 0.52. What is the ratio of the Gross enrolment ratio (%) in Primary schools in 1977 to that in 1985?
Your answer should be compact. 1.03. What is the ratio of the Gross enrolment ratio (%) in Secondary schools in 1977 to that in 1985?
Your answer should be compact. 0.78. What is the ratio of the Gross enrolment ratio (%) of Tertiary schools in 1977 to that in 1985?
Provide a succinct answer. 0.51. What is the ratio of the Gross enrolment ratio (%) in Pre-primary schools in 1977 to that in 1986?
Your response must be concise. 0.48. What is the ratio of the Gross enrolment ratio (%) of Primary schools in 1977 to that in 1986?
Offer a very short reply. 1.03. What is the ratio of the Gross enrolment ratio (%) in Secondary schools in 1977 to that in 1986?
Offer a very short reply. 0.73. What is the ratio of the Gross enrolment ratio (%) in Tertiary schools in 1977 to that in 1986?
Offer a very short reply. 0.53. What is the ratio of the Gross enrolment ratio (%) in Pre-primary schools in 1977 to that in 1987?
Keep it short and to the point. 0.45. What is the ratio of the Gross enrolment ratio (%) in Primary schools in 1977 to that in 1987?
Your response must be concise. 1.01. What is the ratio of the Gross enrolment ratio (%) in Secondary schools in 1977 to that in 1987?
Provide a succinct answer. 0.57. What is the ratio of the Gross enrolment ratio (%) in Tertiary schools in 1977 to that in 1987?
Make the answer very short. 0.52. What is the ratio of the Gross enrolment ratio (%) in Pre-primary schools in 1978 to that in 1982?
Ensure brevity in your answer.  0.73. What is the ratio of the Gross enrolment ratio (%) of Primary schools in 1978 to that in 1982?
Ensure brevity in your answer.  1.03. What is the ratio of the Gross enrolment ratio (%) in Secondary schools in 1978 to that in 1982?
Give a very brief answer. 0.94. What is the ratio of the Gross enrolment ratio (%) in Tertiary schools in 1978 to that in 1982?
Give a very brief answer. 0.9. What is the ratio of the Gross enrolment ratio (%) of Pre-primary schools in 1978 to that in 1985?
Give a very brief answer. 0.57. What is the ratio of the Gross enrolment ratio (%) in Primary schools in 1978 to that in 1985?
Make the answer very short. 1.01. What is the ratio of the Gross enrolment ratio (%) in Secondary schools in 1978 to that in 1985?
Provide a succinct answer. 0.85. What is the ratio of the Gross enrolment ratio (%) of Tertiary schools in 1978 to that in 1985?
Provide a succinct answer. 0.62. What is the ratio of the Gross enrolment ratio (%) in Pre-primary schools in 1978 to that in 1986?
Offer a very short reply. 0.52. What is the ratio of the Gross enrolment ratio (%) in Primary schools in 1978 to that in 1986?
Give a very brief answer. 1.01. What is the ratio of the Gross enrolment ratio (%) in Secondary schools in 1978 to that in 1986?
Offer a very short reply. 0.8. What is the ratio of the Gross enrolment ratio (%) of Tertiary schools in 1978 to that in 1986?
Keep it short and to the point. 0.65. What is the ratio of the Gross enrolment ratio (%) in Pre-primary schools in 1978 to that in 1987?
Ensure brevity in your answer.  0.48. What is the ratio of the Gross enrolment ratio (%) in Primary schools in 1978 to that in 1987?
Offer a terse response. 0.99. What is the ratio of the Gross enrolment ratio (%) of Secondary schools in 1978 to that in 1987?
Ensure brevity in your answer.  0.62. What is the ratio of the Gross enrolment ratio (%) of Tertiary schools in 1978 to that in 1987?
Your response must be concise. 0.63. What is the ratio of the Gross enrolment ratio (%) of Pre-primary schools in 1982 to that in 1985?
Give a very brief answer. 0.78. What is the ratio of the Gross enrolment ratio (%) in Primary schools in 1982 to that in 1985?
Offer a very short reply. 0.98. What is the ratio of the Gross enrolment ratio (%) of Secondary schools in 1982 to that in 1985?
Provide a succinct answer. 0.9. What is the ratio of the Gross enrolment ratio (%) of Tertiary schools in 1982 to that in 1985?
Keep it short and to the point. 0.69. What is the ratio of the Gross enrolment ratio (%) in Pre-primary schools in 1982 to that in 1986?
Keep it short and to the point. 0.71. What is the ratio of the Gross enrolment ratio (%) in Primary schools in 1982 to that in 1986?
Provide a succinct answer. 0.98. What is the ratio of the Gross enrolment ratio (%) of Secondary schools in 1982 to that in 1986?
Offer a very short reply. 0.84. What is the ratio of the Gross enrolment ratio (%) of Tertiary schools in 1982 to that in 1986?
Offer a very short reply. 0.72. What is the ratio of the Gross enrolment ratio (%) in Pre-primary schools in 1982 to that in 1987?
Your answer should be compact. 0.66. What is the ratio of the Gross enrolment ratio (%) in Primary schools in 1982 to that in 1987?
Offer a very short reply. 0.96. What is the ratio of the Gross enrolment ratio (%) in Secondary schools in 1982 to that in 1987?
Your answer should be very brief. 0.66. What is the ratio of the Gross enrolment ratio (%) in Tertiary schools in 1982 to that in 1987?
Provide a short and direct response. 0.7. What is the ratio of the Gross enrolment ratio (%) of Pre-primary schools in 1985 to that in 1986?
Ensure brevity in your answer.  0.91. What is the ratio of the Gross enrolment ratio (%) in Secondary schools in 1985 to that in 1986?
Your answer should be very brief. 0.94. What is the ratio of the Gross enrolment ratio (%) in Tertiary schools in 1985 to that in 1986?
Offer a terse response. 1.04. What is the ratio of the Gross enrolment ratio (%) in Pre-primary schools in 1985 to that in 1987?
Make the answer very short. 0.86. What is the ratio of the Gross enrolment ratio (%) in Primary schools in 1985 to that in 1987?
Your answer should be compact. 0.98. What is the ratio of the Gross enrolment ratio (%) of Secondary schools in 1985 to that in 1987?
Your answer should be very brief. 0.73. What is the ratio of the Gross enrolment ratio (%) in Tertiary schools in 1985 to that in 1987?
Ensure brevity in your answer.  1.01. What is the ratio of the Gross enrolment ratio (%) of Pre-primary schools in 1986 to that in 1987?
Make the answer very short. 0.94. What is the ratio of the Gross enrolment ratio (%) in Secondary schools in 1986 to that in 1987?
Your answer should be very brief. 0.78. What is the ratio of the Gross enrolment ratio (%) in Tertiary schools in 1986 to that in 1987?
Make the answer very short. 0.97. What is the difference between the highest and the second highest Gross enrolment ratio (%) in Pre-primary schools?
Give a very brief answer. 0.41. What is the difference between the highest and the second highest Gross enrolment ratio (%) in Primary schools?
Provide a succinct answer. 1.24. What is the difference between the highest and the second highest Gross enrolment ratio (%) of Secondary schools?
Offer a very short reply. 6.81. What is the difference between the highest and the second highest Gross enrolment ratio (%) in Tertiary schools?
Make the answer very short. 0.31. What is the difference between the highest and the lowest Gross enrolment ratio (%) of Pre-primary schools?
Offer a terse response. 3.72. What is the difference between the highest and the lowest Gross enrolment ratio (%) of Primary schools?
Provide a short and direct response. 6.26. What is the difference between the highest and the lowest Gross enrolment ratio (%) in Secondary schools?
Make the answer very short. 14.97. What is the difference between the highest and the lowest Gross enrolment ratio (%) of Tertiary schools?
Make the answer very short. 17.25. 